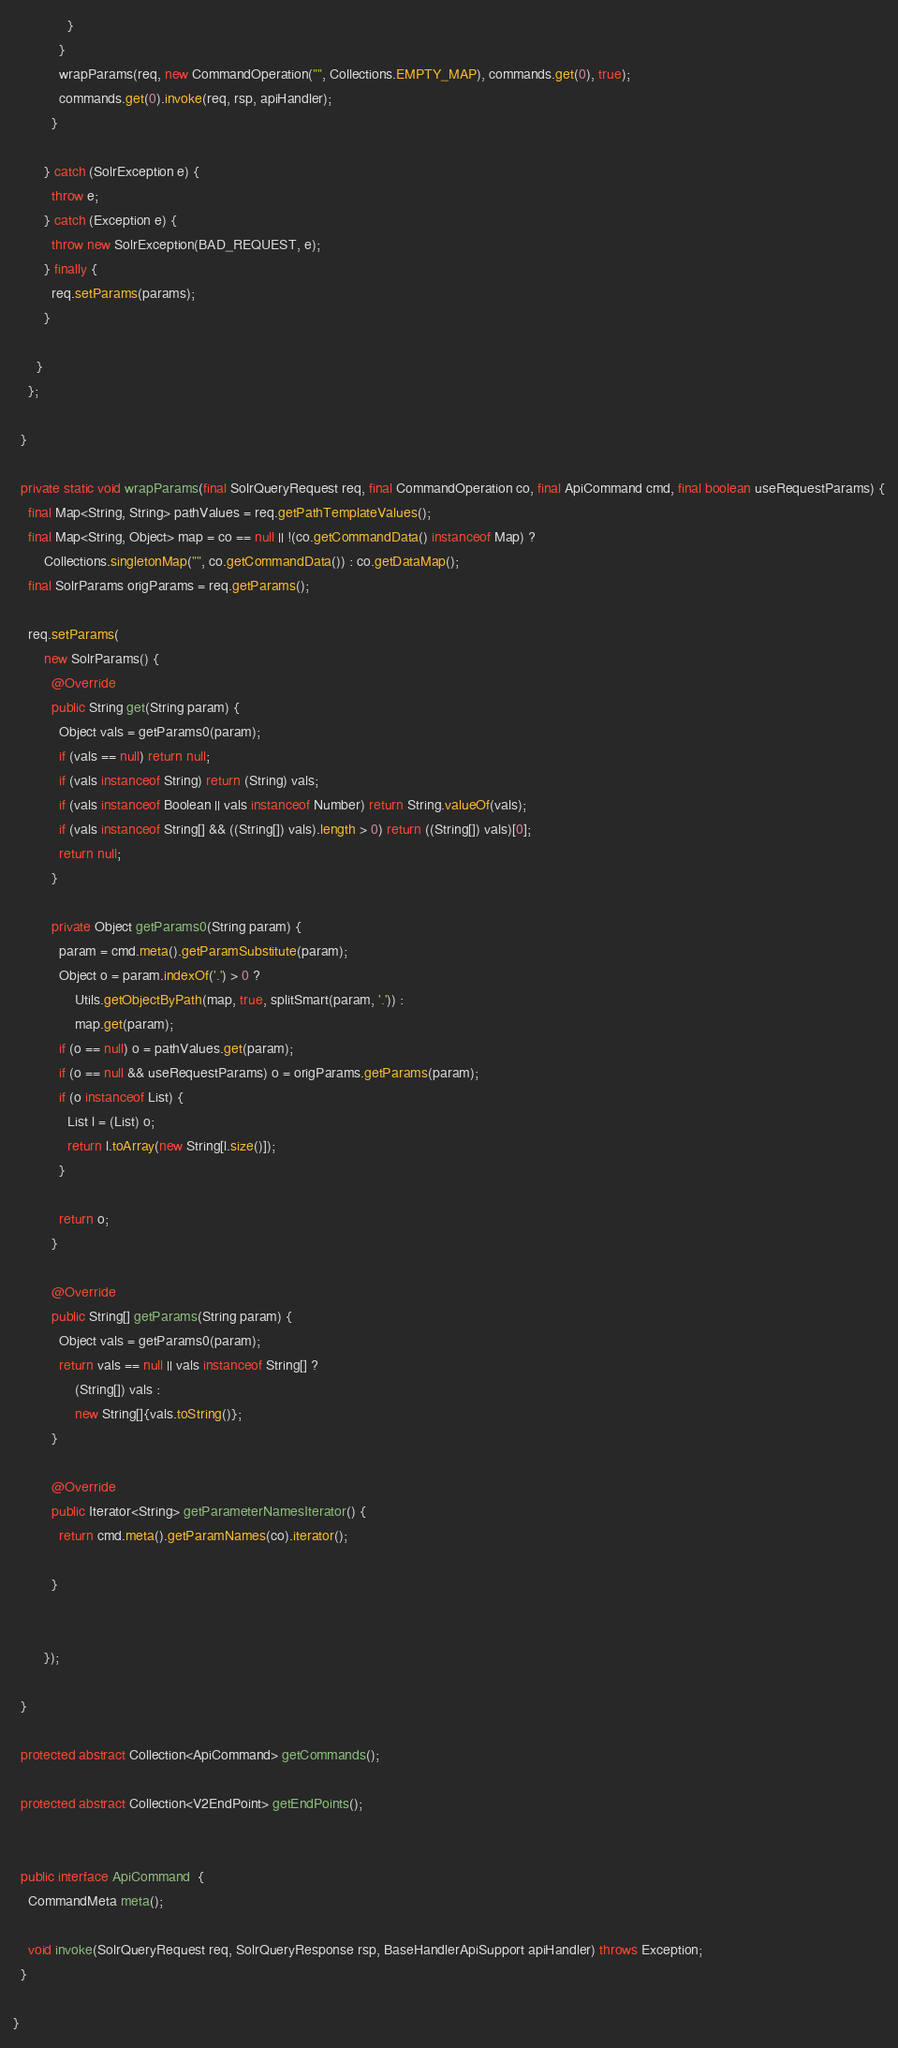<code> <loc_0><loc_0><loc_500><loc_500><_Java_>              }
            }
            wrapParams(req, new CommandOperation("", Collections.EMPTY_MAP), commands.get(0), true);
            commands.get(0).invoke(req, rsp, apiHandler);
          }

        } catch (SolrException e) {
          throw e;
        } catch (Exception e) {
          throw new SolrException(BAD_REQUEST, e);
        } finally {
          req.setParams(params);
        }

      }
    };

  }

  private static void wrapParams(final SolrQueryRequest req, final CommandOperation co, final ApiCommand cmd, final boolean useRequestParams) {
    final Map<String, String> pathValues = req.getPathTemplateValues();
    final Map<String, Object> map = co == null || !(co.getCommandData() instanceof Map) ?
        Collections.singletonMap("", co.getCommandData()) : co.getDataMap();
    final SolrParams origParams = req.getParams();

    req.setParams(
        new SolrParams() {
          @Override
          public String get(String param) {
            Object vals = getParams0(param);
            if (vals == null) return null;
            if (vals instanceof String) return (String) vals;
            if (vals instanceof Boolean || vals instanceof Number) return String.valueOf(vals);
            if (vals instanceof String[] && ((String[]) vals).length > 0) return ((String[]) vals)[0];
            return null;
          }

          private Object getParams0(String param) {
            param = cmd.meta().getParamSubstitute(param);
            Object o = param.indexOf('.') > 0 ?
                Utils.getObjectByPath(map, true, splitSmart(param, '.')) :
                map.get(param);
            if (o == null) o = pathValues.get(param);
            if (o == null && useRequestParams) o = origParams.getParams(param);
            if (o instanceof List) {
              List l = (List) o;
              return l.toArray(new String[l.size()]);
            }

            return o;
          }

          @Override
          public String[] getParams(String param) {
            Object vals = getParams0(param);
            return vals == null || vals instanceof String[] ?
                (String[]) vals :
                new String[]{vals.toString()};
          }

          @Override
          public Iterator<String> getParameterNamesIterator() {
            return cmd.meta().getParamNames(co).iterator();

          }


        });

  }

  protected abstract Collection<ApiCommand> getCommands();

  protected abstract Collection<V2EndPoint> getEndPoints();


  public interface ApiCommand  {
    CommandMeta meta();

    void invoke(SolrQueryRequest req, SolrQueryResponse rsp, BaseHandlerApiSupport apiHandler) throws Exception;
  }

}
</code> 